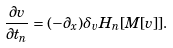<formula> <loc_0><loc_0><loc_500><loc_500>\frac { \partial v } { \partial t _ { n } } = ( - \partial _ { x } ) \delta _ { v } H _ { n } [ M [ v ] ] .</formula> 